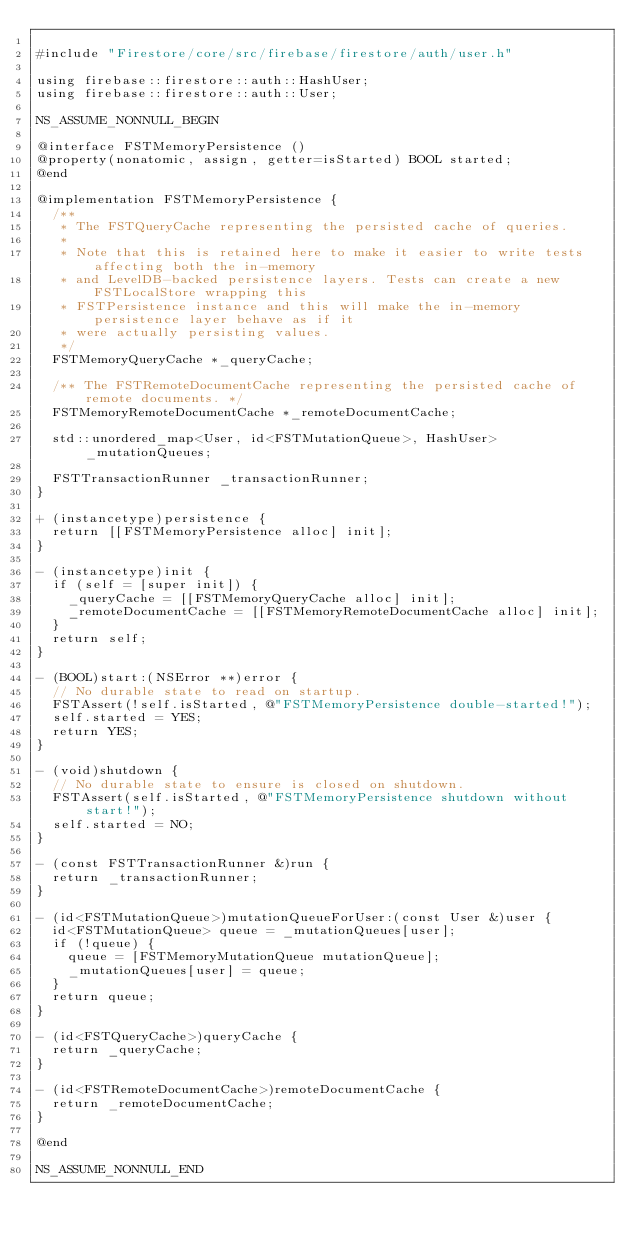Convert code to text. <code><loc_0><loc_0><loc_500><loc_500><_ObjectiveC_>
#include "Firestore/core/src/firebase/firestore/auth/user.h"

using firebase::firestore::auth::HashUser;
using firebase::firestore::auth::User;

NS_ASSUME_NONNULL_BEGIN

@interface FSTMemoryPersistence ()
@property(nonatomic, assign, getter=isStarted) BOOL started;
@end

@implementation FSTMemoryPersistence {
  /**
   * The FSTQueryCache representing the persisted cache of queries.
   *
   * Note that this is retained here to make it easier to write tests affecting both the in-memory
   * and LevelDB-backed persistence layers. Tests can create a new FSTLocalStore wrapping this
   * FSTPersistence instance and this will make the in-memory persistence layer behave as if it
   * were actually persisting values.
   */
  FSTMemoryQueryCache *_queryCache;

  /** The FSTRemoteDocumentCache representing the persisted cache of remote documents. */
  FSTMemoryRemoteDocumentCache *_remoteDocumentCache;

  std::unordered_map<User, id<FSTMutationQueue>, HashUser> _mutationQueues;

  FSTTransactionRunner _transactionRunner;
}

+ (instancetype)persistence {
  return [[FSTMemoryPersistence alloc] init];
}

- (instancetype)init {
  if (self = [super init]) {
    _queryCache = [[FSTMemoryQueryCache alloc] init];
    _remoteDocumentCache = [[FSTMemoryRemoteDocumentCache alloc] init];
  }
  return self;
}

- (BOOL)start:(NSError **)error {
  // No durable state to read on startup.
  FSTAssert(!self.isStarted, @"FSTMemoryPersistence double-started!");
  self.started = YES;
  return YES;
}

- (void)shutdown {
  // No durable state to ensure is closed on shutdown.
  FSTAssert(self.isStarted, @"FSTMemoryPersistence shutdown without start!");
  self.started = NO;
}

- (const FSTTransactionRunner &)run {
  return _transactionRunner;
}

- (id<FSTMutationQueue>)mutationQueueForUser:(const User &)user {
  id<FSTMutationQueue> queue = _mutationQueues[user];
  if (!queue) {
    queue = [FSTMemoryMutationQueue mutationQueue];
    _mutationQueues[user] = queue;
  }
  return queue;
}

- (id<FSTQueryCache>)queryCache {
  return _queryCache;
}

- (id<FSTRemoteDocumentCache>)remoteDocumentCache {
  return _remoteDocumentCache;
}

@end

NS_ASSUME_NONNULL_END
</code> 